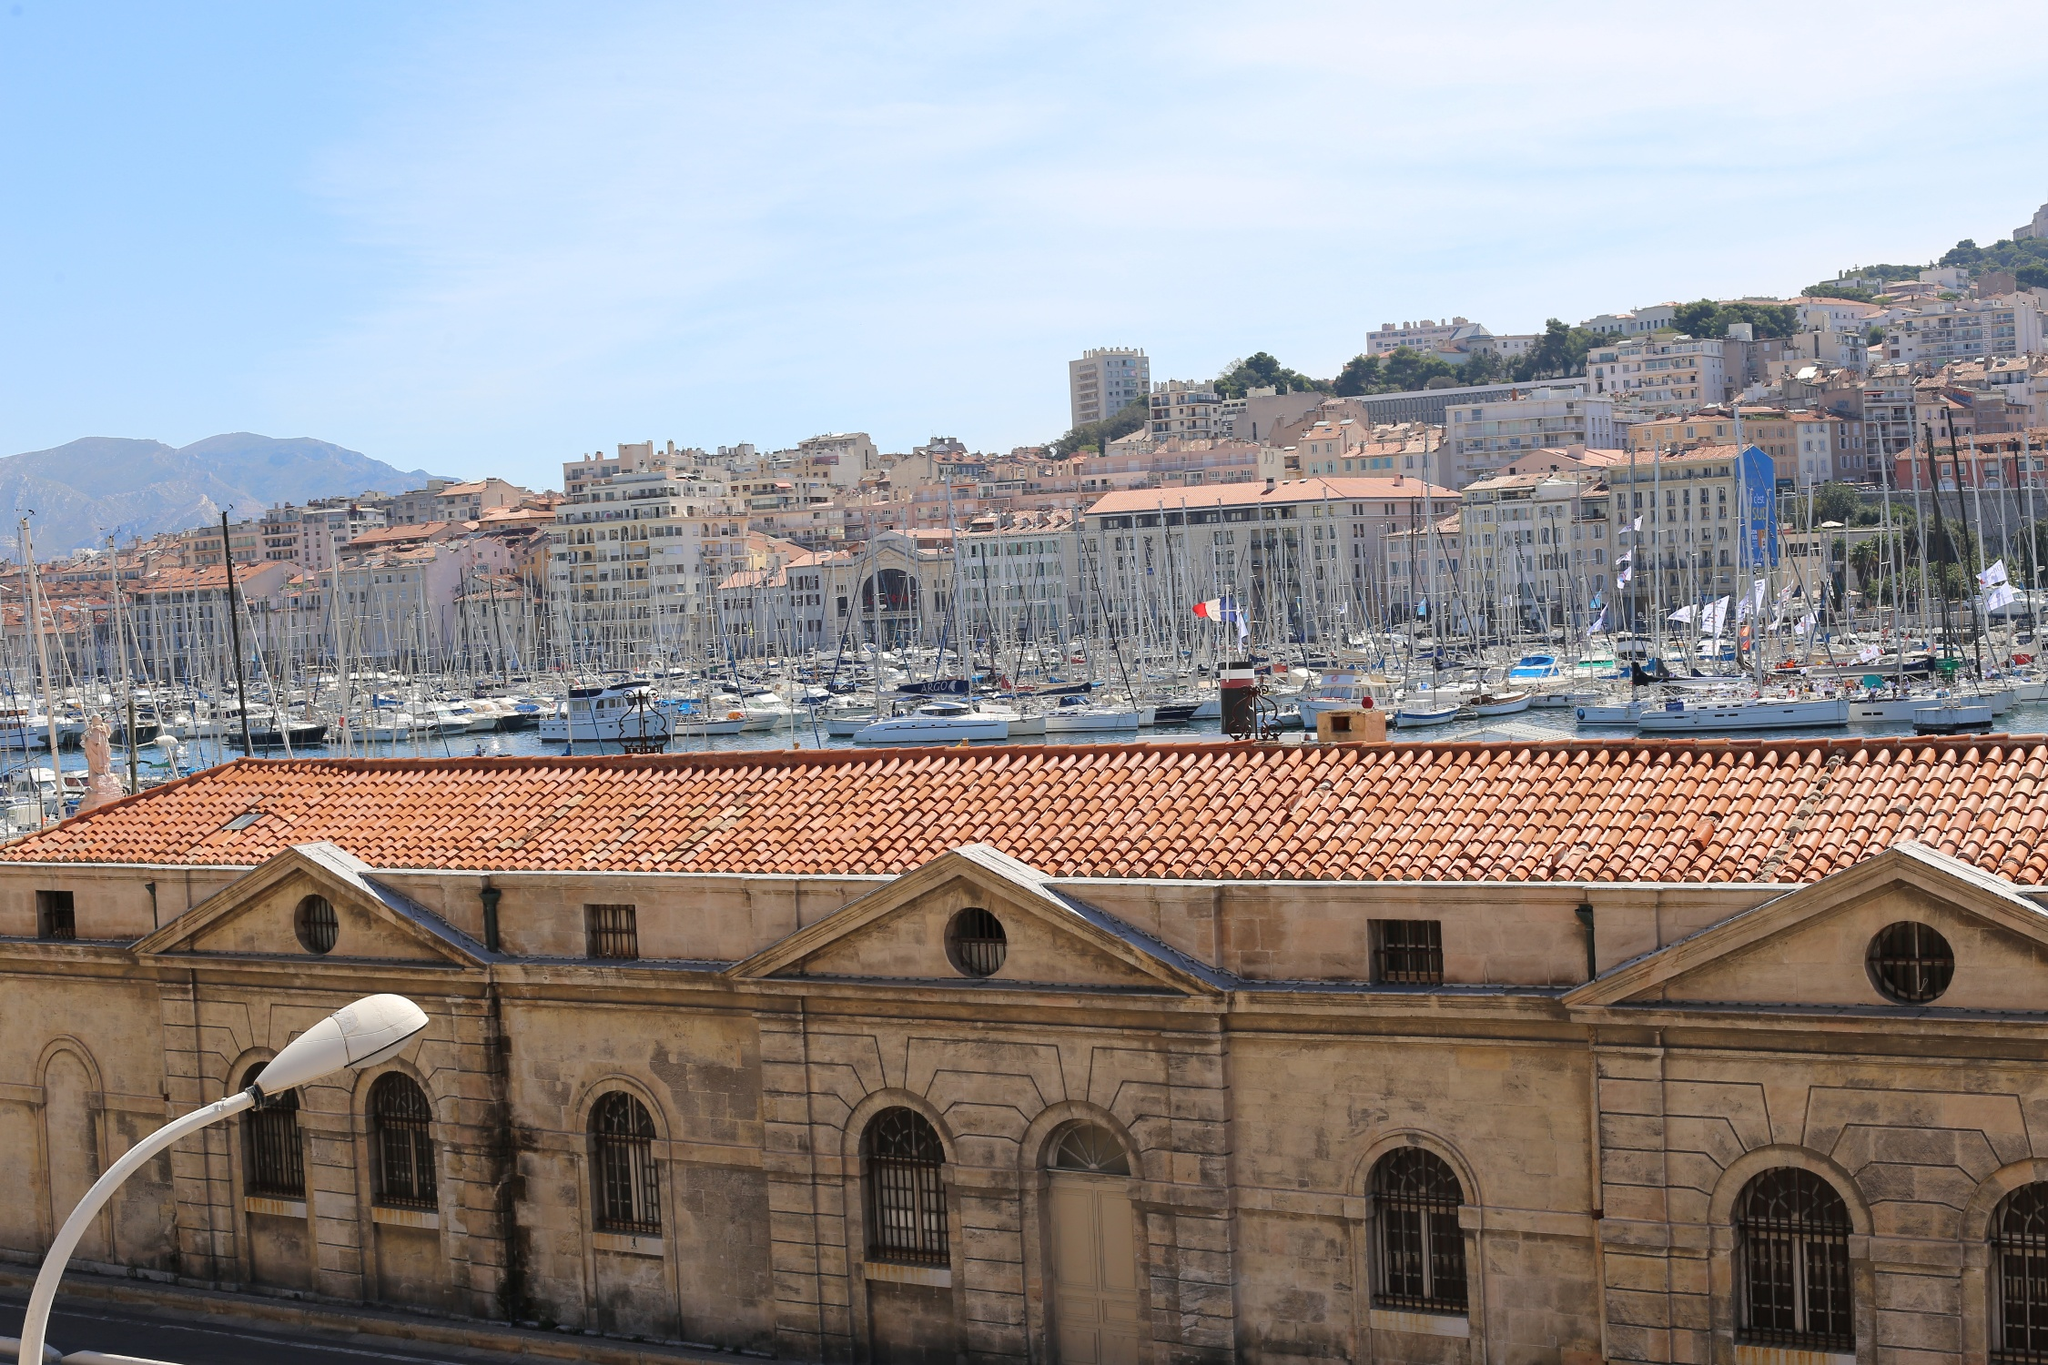Imagine a festival being held at the Old Port of Marseille. What might that look like? Imagine the Old Port of Marseille transformed into a spectacular festival scene. Brightly colored banners and flags flutter in the gentle sea breeze, decorating the marina and the streets with a festive atmosphere. Stalls line the waterfront, offering a variety of local delicacies, from freshly caught seafood to traditional Provençal dishes. The aroma of grilled fish and herbs wafts through the air, mingling with the sounds of laughter and music. Street performers entertain the crowds with their acts, while local musicians play lively tunes, adding to the vibrant ambiance. Boats in the harbor are adorned with lights and decorations, creating a picturesque and joyful sight. As the sun sets, the evening sky is lit up with fireworks, their reflections dancing on the water, signaling the peak of the celebrations. The festival at the Old Port of Marseille would be a mesmerizing blend of culture, cuisine, and community spirit, leaving lasting memories for all who attend. 